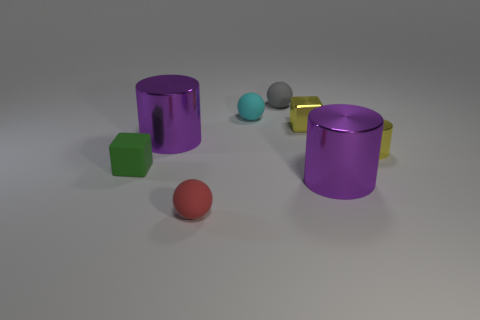There is a thing that is the same color as the small metallic cube; what is its size?
Provide a succinct answer. Small. Does the metal cube have the same color as the tiny shiny cylinder?
Keep it short and to the point. Yes. Does the small cyan object have the same material as the gray sphere behind the red thing?
Give a very brief answer. Yes. The matte block has what color?
Your answer should be very brief. Green. There is a purple metallic object that is to the right of the small gray object; what shape is it?
Offer a very short reply. Cylinder. How many yellow things are small rubber cubes or metallic cubes?
Provide a succinct answer. 1. What color is the block that is made of the same material as the tiny gray thing?
Keep it short and to the point. Green. There is a tiny cylinder; does it have the same color as the sphere in front of the small yellow cylinder?
Give a very brief answer. No. There is a object that is both in front of the green rubber cube and right of the small metal cube; what color is it?
Offer a terse response. Purple. There is a red rubber thing; what number of small green rubber things are right of it?
Your response must be concise. 0. 